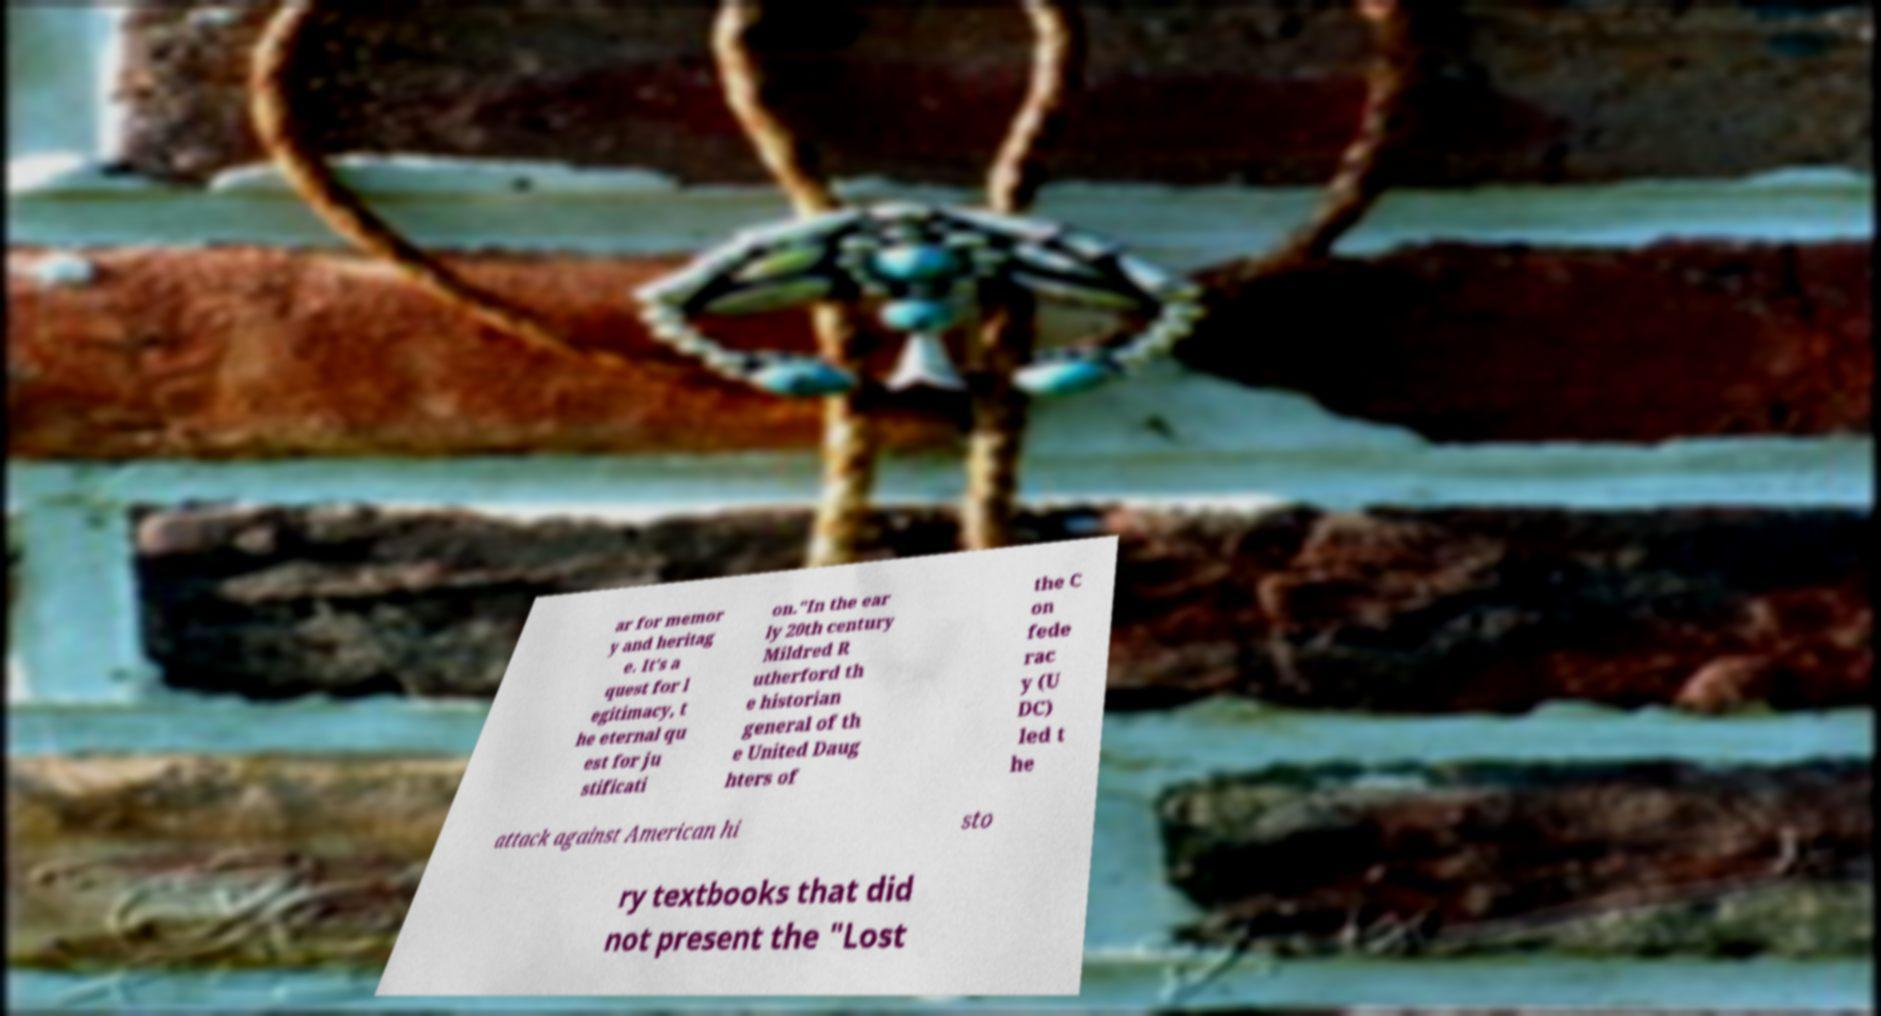I need the written content from this picture converted into text. Can you do that? ar for memor y and heritag e. It's a quest for l egitimacy, t he eternal qu est for ju stificati on."In the ear ly 20th century Mildred R utherford th e historian general of th e United Daug hters of the C on fede rac y (U DC) led t he attack against American hi sto ry textbooks that did not present the "Lost 